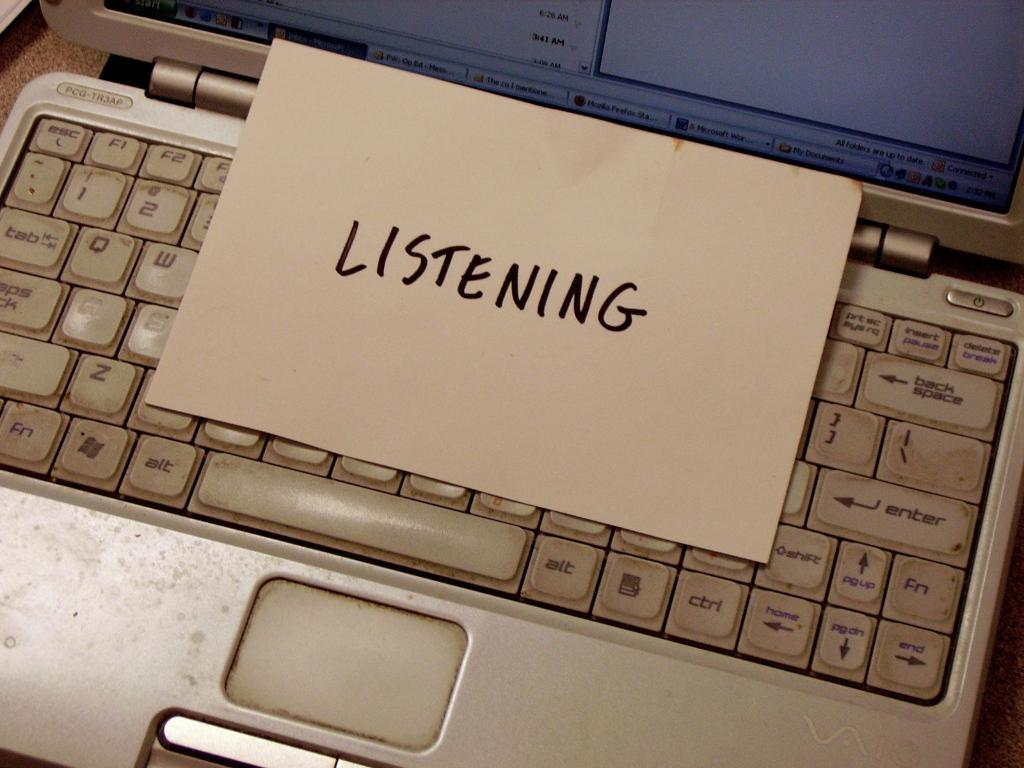<image>
Share a concise interpretation of the image provided. On a laptop keyboard is a piece of paper that says Listening 